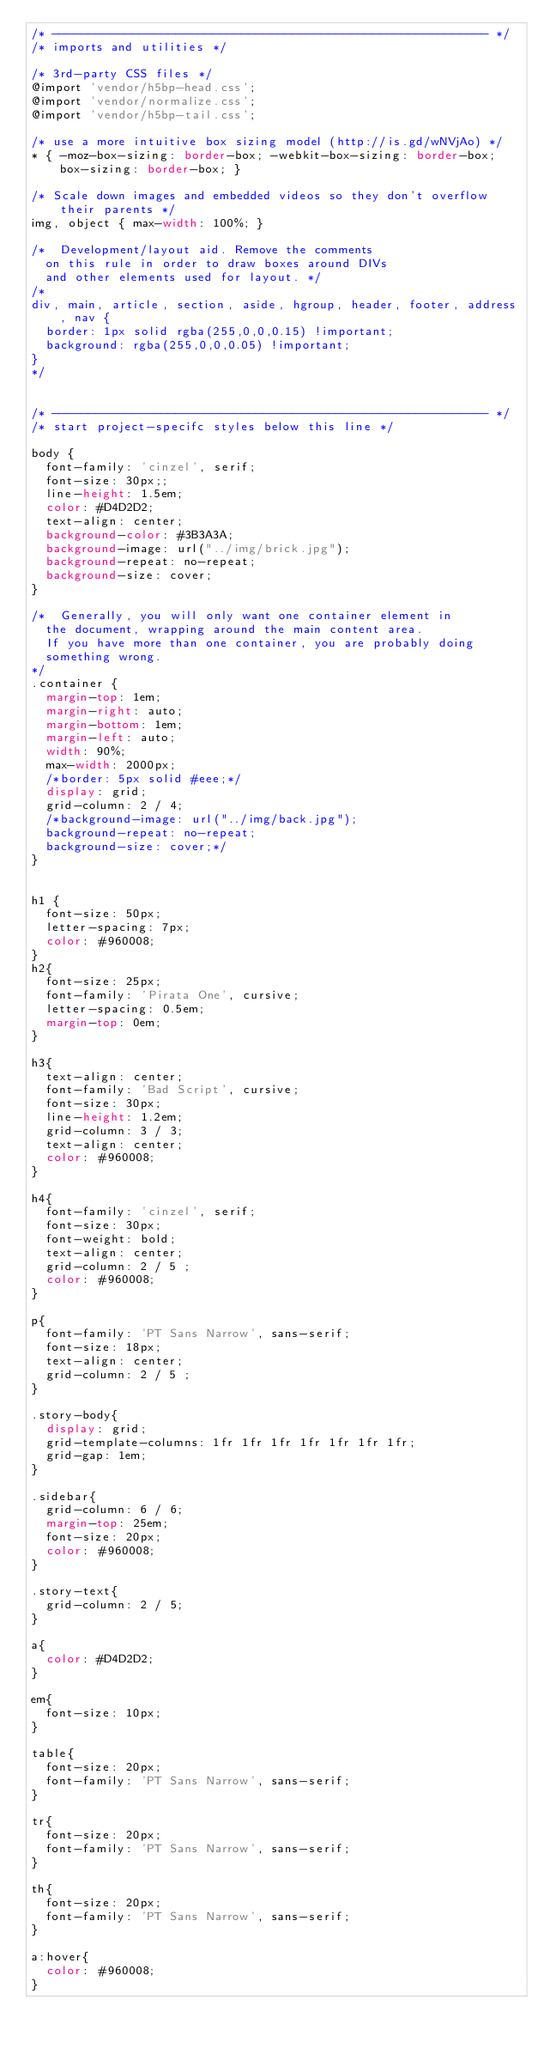<code> <loc_0><loc_0><loc_500><loc_500><_CSS_>/* ------------------------------------------------------------ */
/* imports and utilities */

/* 3rd-party CSS files */
@import 'vendor/h5bp-head.css';
@import 'vendor/normalize.css';
@import 'vendor/h5bp-tail.css';

/* use a more intuitive box sizing model (http://is.gd/wNVjAo) */
* { -moz-box-sizing: border-box; -webkit-box-sizing: border-box; box-sizing: border-box; }

/* Scale down images and embedded videos so they don't overflow their parents */
img, object { max-width: 100%; }

/*	Development/layout aid. Remove the comments
	on this rule in order to draw boxes around DIVs
	and other elements used for layout. */
/* 
div, main, article, section, aside, hgroup, header, footer, address, nav {
	border: 1px solid rgba(255,0,0,0.15) !important;
	background: rgba(255,0,0,0.05) !important;		
}
*/


/* ------------------------------------------------------------ */
/* start project-specifc styles below this line */

body {
	font-family: 'cinzel', serif;
	font-size: 30px;;
	line-height: 1.5em;
	color: #D4D2D2;
	text-align: center;
	background-color: #3B3A3A;
	background-image: url("../img/brick.jpg");
	background-repeat: no-repeat;
	background-size: cover;
}

/*	Generally, you will only want one container element in
	the document, wrapping around the main content area. 
	If you have more than one container, you are probably doing
	something wrong. 	
*/
.container {
	margin-top: 1em;
	margin-right: auto;
	margin-bottom: 1em;
	margin-left: auto;
	width: 90%;
	max-width: 2000px;
	/*border: 5px solid #eee;*/
	display: grid;
	grid-column: 2 / 4;
	/*background-image: url("../img/back.jpg");
	background-repeat: no-repeat;
	background-size: cover;*/
}


h1 { 
	font-size: 50px;
	letter-spacing: 7px;
	color: #960008;
}
h2{
	font-size: 25px;
	font-family: 'Pirata One', cursive;
	letter-spacing: 0.5em;
	margin-top: 0em;
}

h3{
	text-align: center;
	font-family: 'Bad Script', cursive;
	font-size: 30px;
	line-height: 1.2em;
	grid-column: 3 / 3;
	text-align: center;
	color: #960008;
}

h4{
	font-family: 'cinzel', serif;
	font-size: 30px;
	font-weight: bold;
	text-align: center;
	grid-column: 2 / 5 ;
	color: #960008;
}

p{
	font-family: 'PT Sans Narrow', sans-serif; 
	font-size: 18px;
	text-align: center;
	grid-column: 2 / 5 ;
}

.story-body{
	display: grid;
	grid-template-columns: 1fr 1fr 1fr 1fr 1fr 1fr 1fr;
	grid-gap: 1em;
}

.sidebar{
	grid-column: 6 / 6;
	margin-top: 25em;
	font-size: 20px;
	color: #960008;
}

.story-text{
	grid-column: 2 / 5;
}

a{
	color: #D4D2D2;
}

em{
	font-size: 10px;
}

table{
	font-size: 20px;
	font-family: 'PT Sans Narrow', sans-serif;
}

tr{
	font-size: 20px;
	font-family: 'PT Sans Narrow', sans-serif;
}

th{
	font-size: 20px;
	font-family: 'PT Sans Narrow', sans-serif;
}

a:hover{
	color: #960008;
}
</code> 